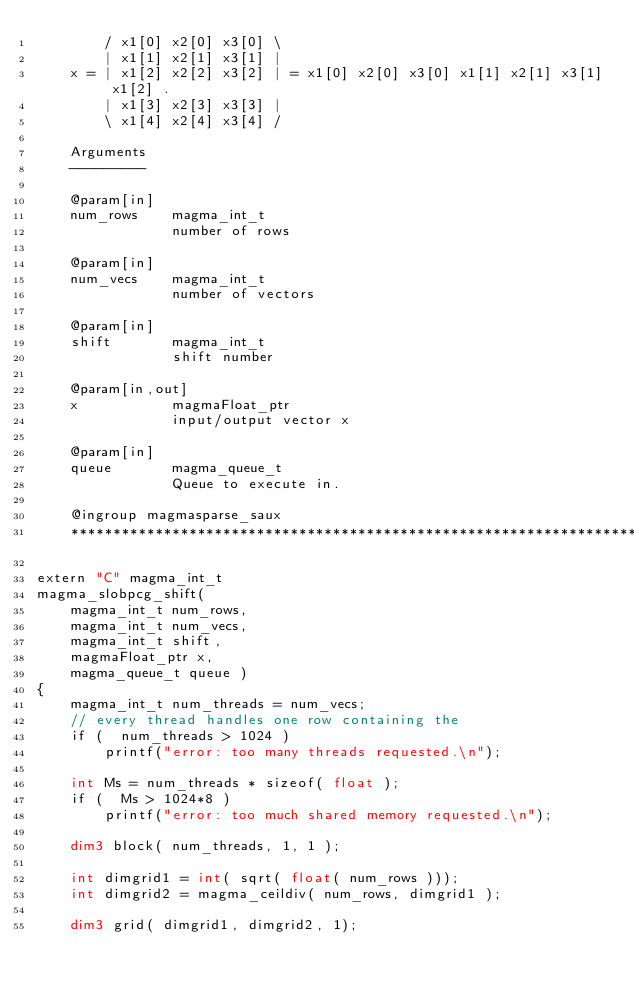Convert code to text. <code><loc_0><loc_0><loc_500><loc_500><_Cuda_>        / x1[0] x2[0] x3[0] \
        | x1[1] x2[1] x3[1] |
    x = | x1[2] x2[2] x3[2] | = x1[0] x2[0] x3[0] x1[1] x2[1] x3[1] x1[2] .
        | x1[3] x2[3] x3[3] |
        \ x1[4] x2[4] x3[4] /
    
    Arguments
    ---------

    @param[in]
    num_rows    magma_int_t
                number of rows

    @param[in]
    num_vecs    magma_int_t
                number of vectors

    @param[in]
    shift       magma_int_t
                shift number

    @param[in,out]
    x           magmaFloat_ptr 
                input/output vector x

    @param[in]
    queue       magma_queue_t
                Queue to execute in.

    @ingroup magmasparse_saux
    ********************************************************************/

extern "C" magma_int_t
magma_slobpcg_shift(
    magma_int_t num_rows,
    magma_int_t num_vecs, 
    magma_int_t shift,
    magmaFloat_ptr x,
    magma_queue_t queue )
{
    magma_int_t num_threads = num_vecs;
    // every thread handles one row containing the 
    if (  num_threads > 1024 )
        printf("error: too many threads requested.\n");

    int Ms = num_threads * sizeof( float );
    if (  Ms > 1024*8 )
        printf("error: too much shared memory requested.\n");

    dim3 block( num_threads, 1, 1 );

    int dimgrid1 = int( sqrt( float( num_rows )));
    int dimgrid2 = magma_ceildiv( num_rows, dimgrid1 );

    dim3 grid( dimgrid1, dimgrid2, 1);
</code> 